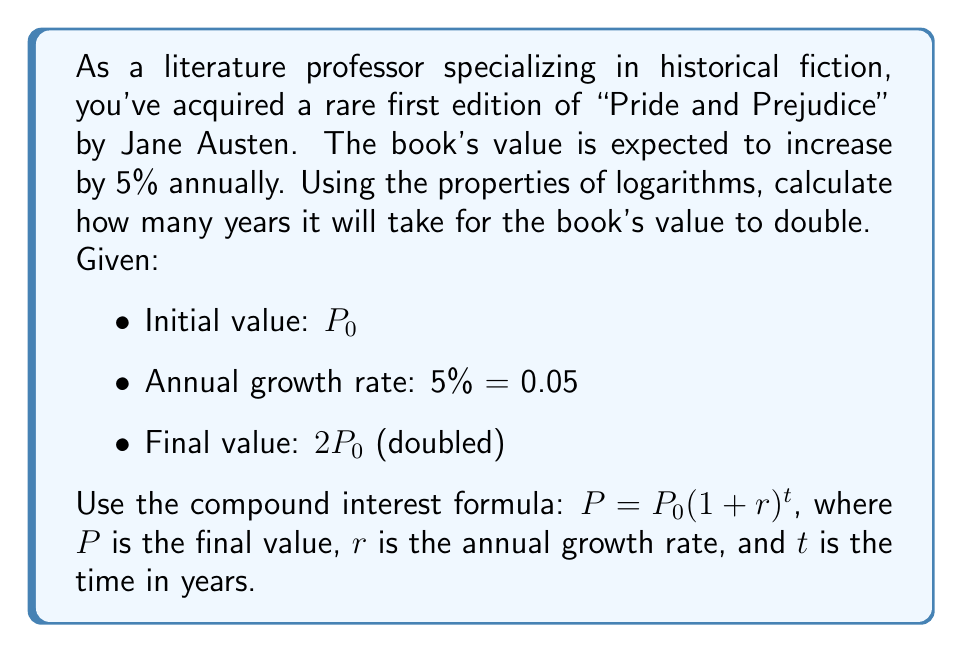Give your solution to this math problem. Let's approach this step-by-step using logarithmic properties:

1) We start with the compound interest formula:
   $P = P_0(1 + r)^t$

2) In our case, $P = 2P_0$ (the value has doubled) and $r = 0.05$:
   $2P_0 = P_0(1 + 0.05)^t$

3) Divide both sides by $P_0$:
   $2 = (1 + 0.05)^t = (1.05)^t$

4) Now, let's take the natural logarithm of both sides:
   $\ln(2) = \ln((1.05)^t)$

5) Using the logarithm property $\ln(a^b) = b\ln(a)$:
   $\ln(2) = t\ln(1.05)$

6) Solve for $t$ by dividing both sides by $\ln(1.05)$:
   $t = \frac{\ln(2)}{\ln(1.05)}$

7) Calculate the result:
   $t = \frac{0.6931471806}{0.0487901142} \approx 14.2067$

Therefore, it will take approximately 14.21 years for the book's value to double.
Answer: $t \approx 14.21$ years 